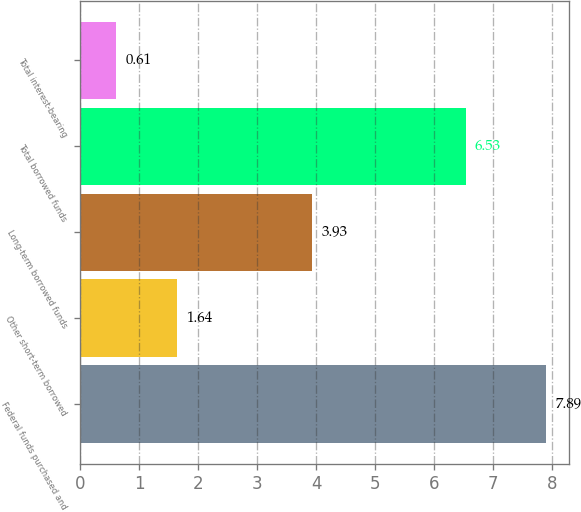Convert chart. <chart><loc_0><loc_0><loc_500><loc_500><bar_chart><fcel>Federal funds purchased and<fcel>Other short-term borrowed<fcel>Long-term borrowed funds<fcel>Total borrowed funds<fcel>Total interest-bearing<nl><fcel>7.89<fcel>1.64<fcel>3.93<fcel>6.53<fcel>0.61<nl></chart> 